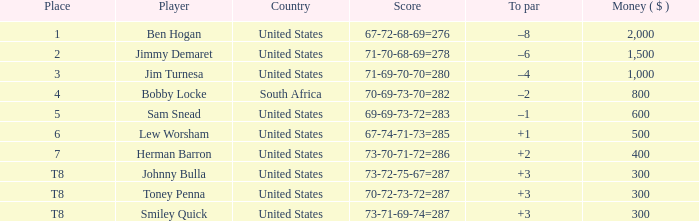What is the Place of the Player with Money greater than 300 and a Score of 71-69-70-70=280? 3.0. 